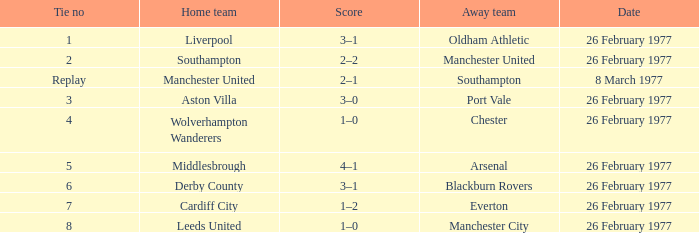Which was the host team that competed against manchester united? Southampton. 